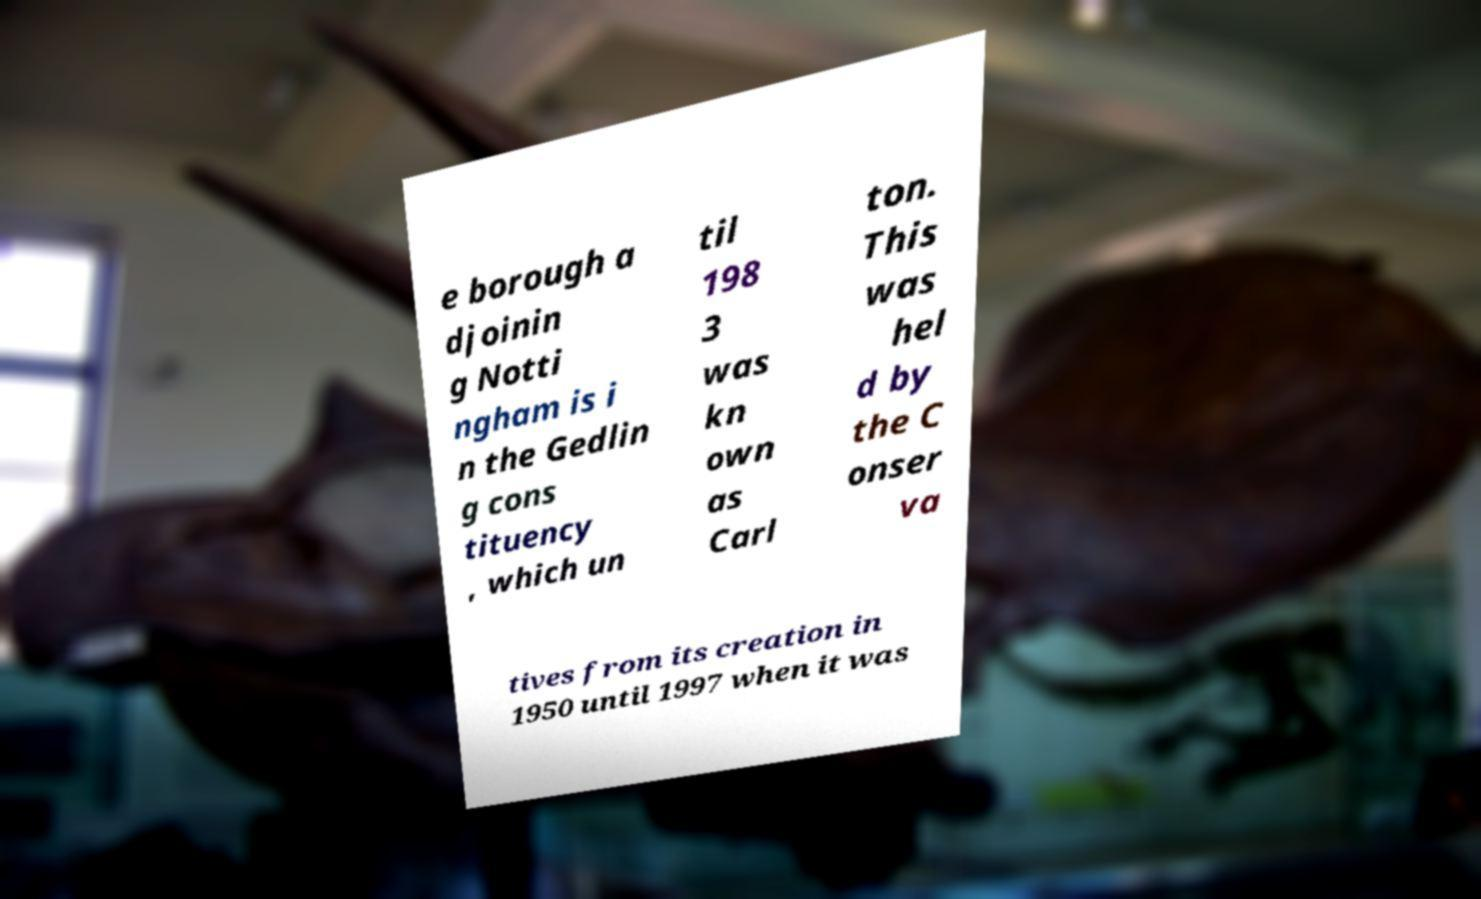For documentation purposes, I need the text within this image transcribed. Could you provide that? e borough a djoinin g Notti ngham is i n the Gedlin g cons tituency , which un til 198 3 was kn own as Carl ton. This was hel d by the C onser va tives from its creation in 1950 until 1997 when it was 